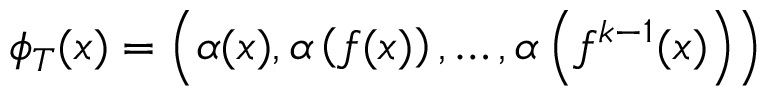<formula> <loc_0><loc_0><loc_500><loc_500>\phi _ { T } ( x ) = \left ( \alpha ( x ) , \alpha \left ( f ( x ) \right ) , \dots , \alpha \left ( f ^ { k - 1 } ( x ) \right ) \right )</formula> 